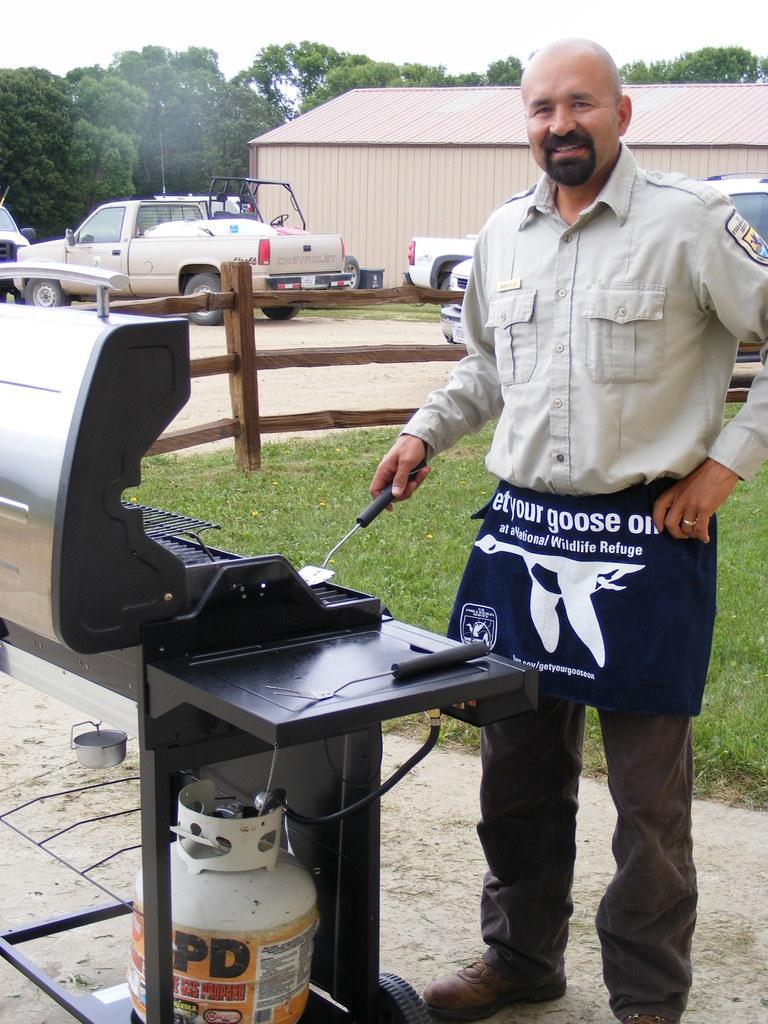<image>
Provide a brief description of the given image. A man with the word "goose" on his apron cooks at a grill. 